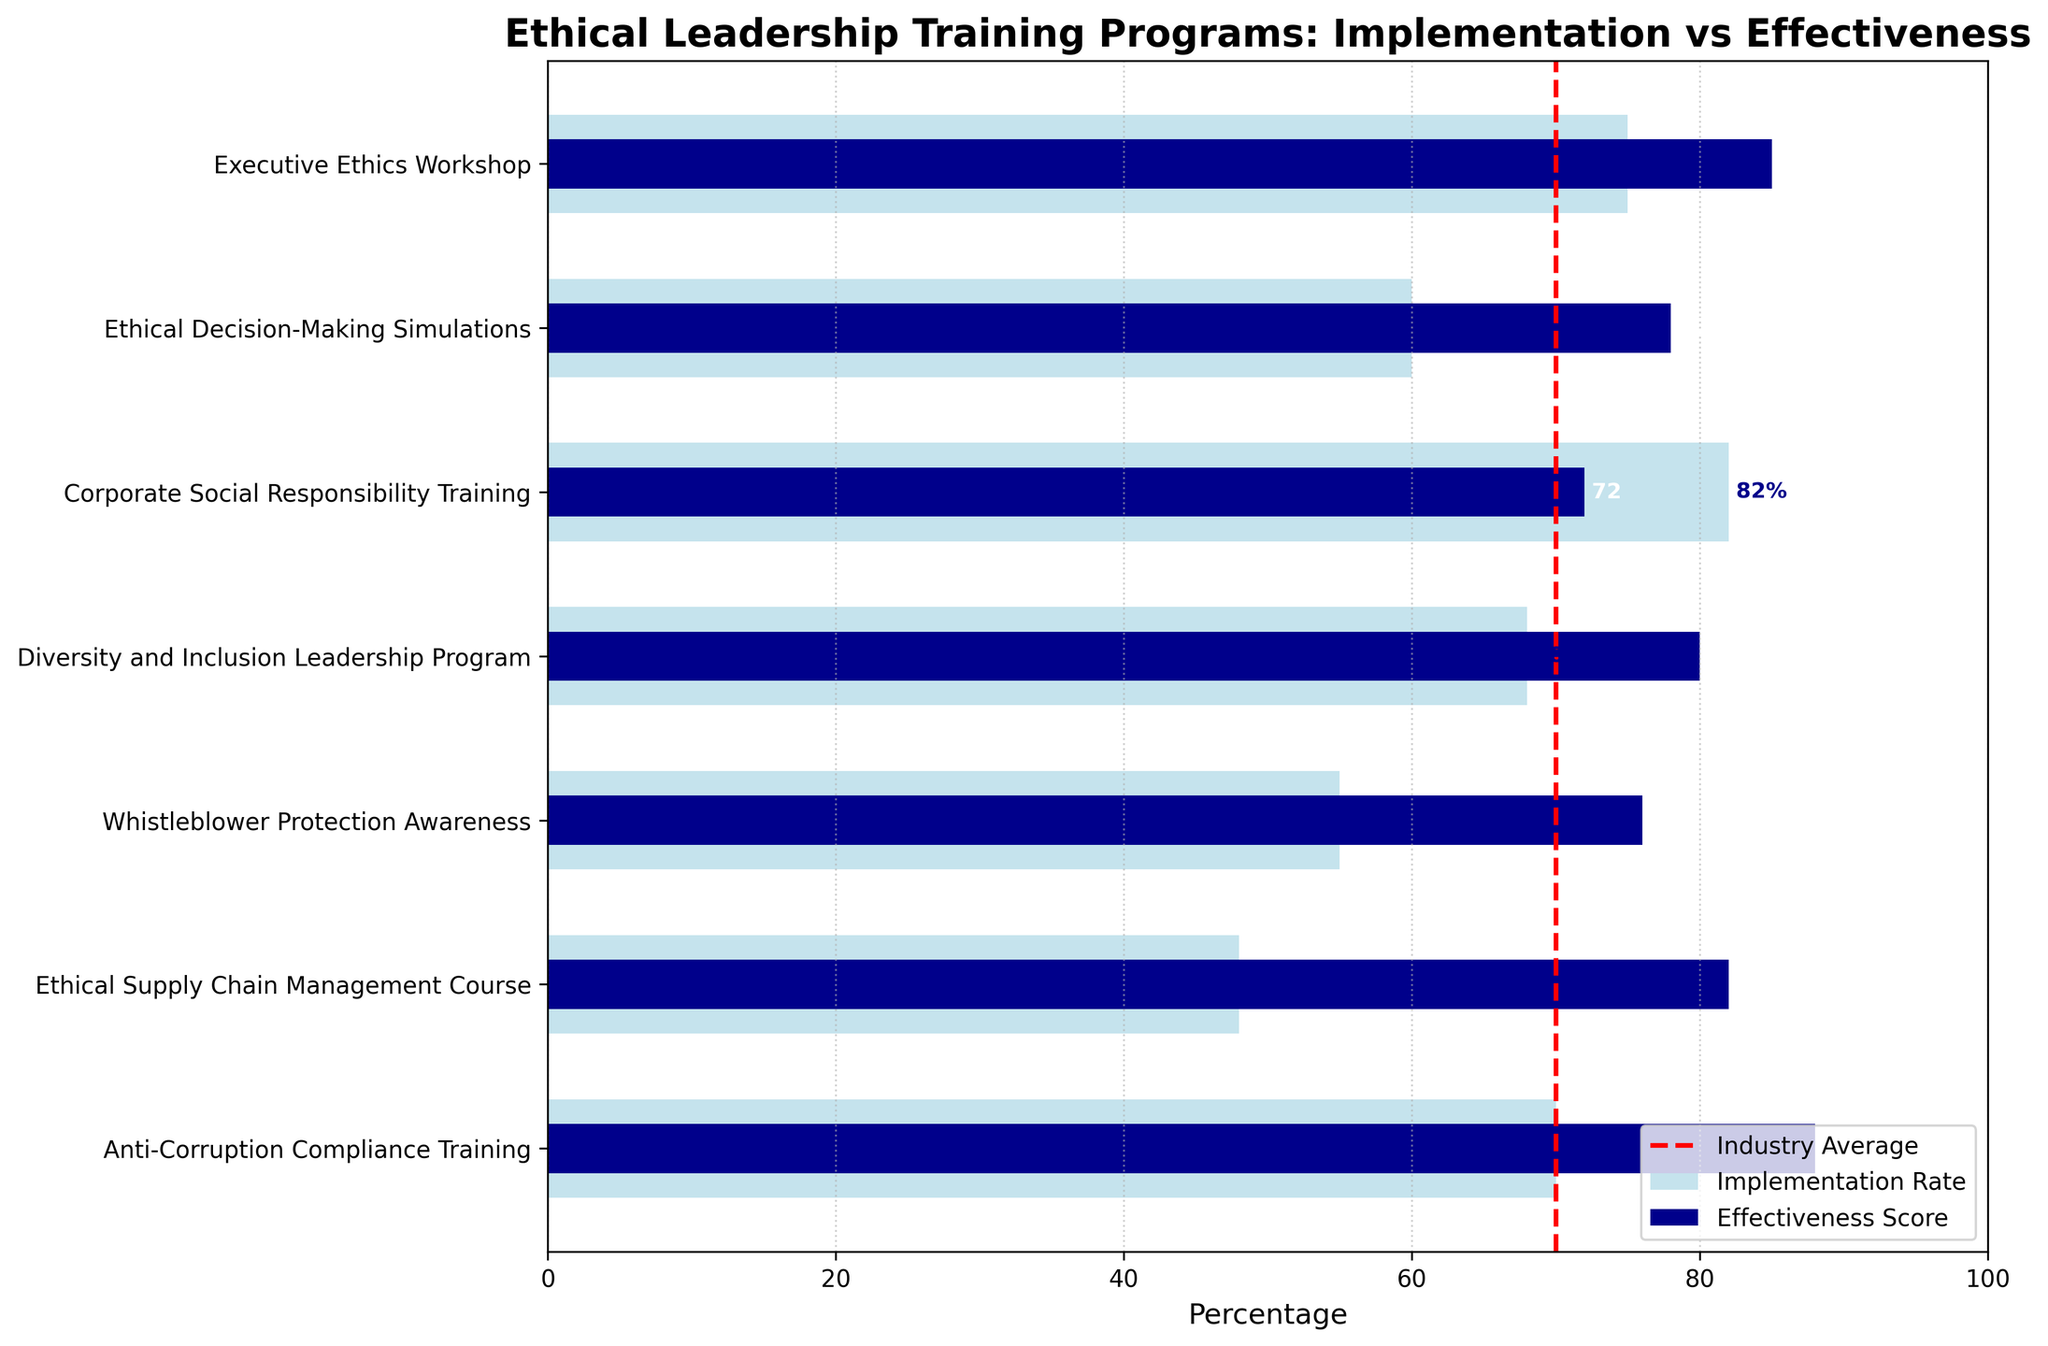What's the title of the chart? The title of the chart is located at the top and states the main subject of the visual. Here, the title is "Ethical Leadership Training Programs: Implementation vs Effectiveness."
Answer: Ethical Leadership Training Programs: Implementation vs Effectiveness What does the red dashed line represent? The red dashed line in the chart is a reference line used to indicate the industry average percentage for these ethical leadership training programs. It is labeled on the legend as "Industry Average."
Answer: Industry Average Which program has the highest implementation rate? Identify the longest light blue bar on the chart, which represents the implementation rate for each program. The "Corporate Social Responsibility Training" has the highest implementation rate at 82%.
Answer: Corporate Social Responsibility Training Compare the effectiveness score of the "Diversity and Inclusion Leadership Program" to its implementation rate. The effectiveness score is represented by the shorter dark blue bar, while the implementation rate is represented by the longer light blue bar. For the "Diversity and Inclusion Leadership Program," the effectiveness score is 80%, and the implementation rate is 68%.
Answer: Effectiveness score (80%) is higher than the implementation rate (68%) Which program has the largest difference between its implementation rate and effectiveness score? To determine this, calculate the difference between the implementation rate and effectiveness score for each program and identify the largest difference. "Whistleblower Protection Awareness" has an implementation rate of 55% and effectiveness score of 76%, leading to a 21% difference.
Answer: Whistleblower Protection Awareness How does the effectiveness score of the "Ethical Supply Chain Management Course" compare to the industry average? The effectiveness score of the "Ethical Supply Chain Management Course" can be found to the right of the blue bar for this program. The effectiveness score is 82%, and the industry average is indicated by the red dashed line at 70%. Thus, the effectiveness score is higher than the industry average.
Answer: Higher than the industry average Calculate the average implementation rate across all programs. Sum all implementation rates and divide by the total number of programs: (75 + 60 + 82 + 68 + 55 + 48 + 70) / 7, which equals 458 / 7 = 65.43%.
Answer: 65.43% Is there any program with an effectiveness score equal to or above 85%? If yes, name them. Check the effectiveness scores listed to see if any are 85% or above. Both the "Anti-Corruption Compliance Training" at 88% and "Executive Ethics Workshop" at 85% meet this criterion.
Answer: Anti-Corruption Compliance Training, Executive Ethics Workshop Which program has the lowest implementation rate and how does its effectiveness score compare to the industry average? The program with the shortest light blue bar, representing the implementation rate, is "Ethical Supply Chain Management Course" at 48%. Its effectiveness score of 82% is higher than the industry average of 70%.
Answer: Ethical Supply Chain Management Course; higher effectiveness score 